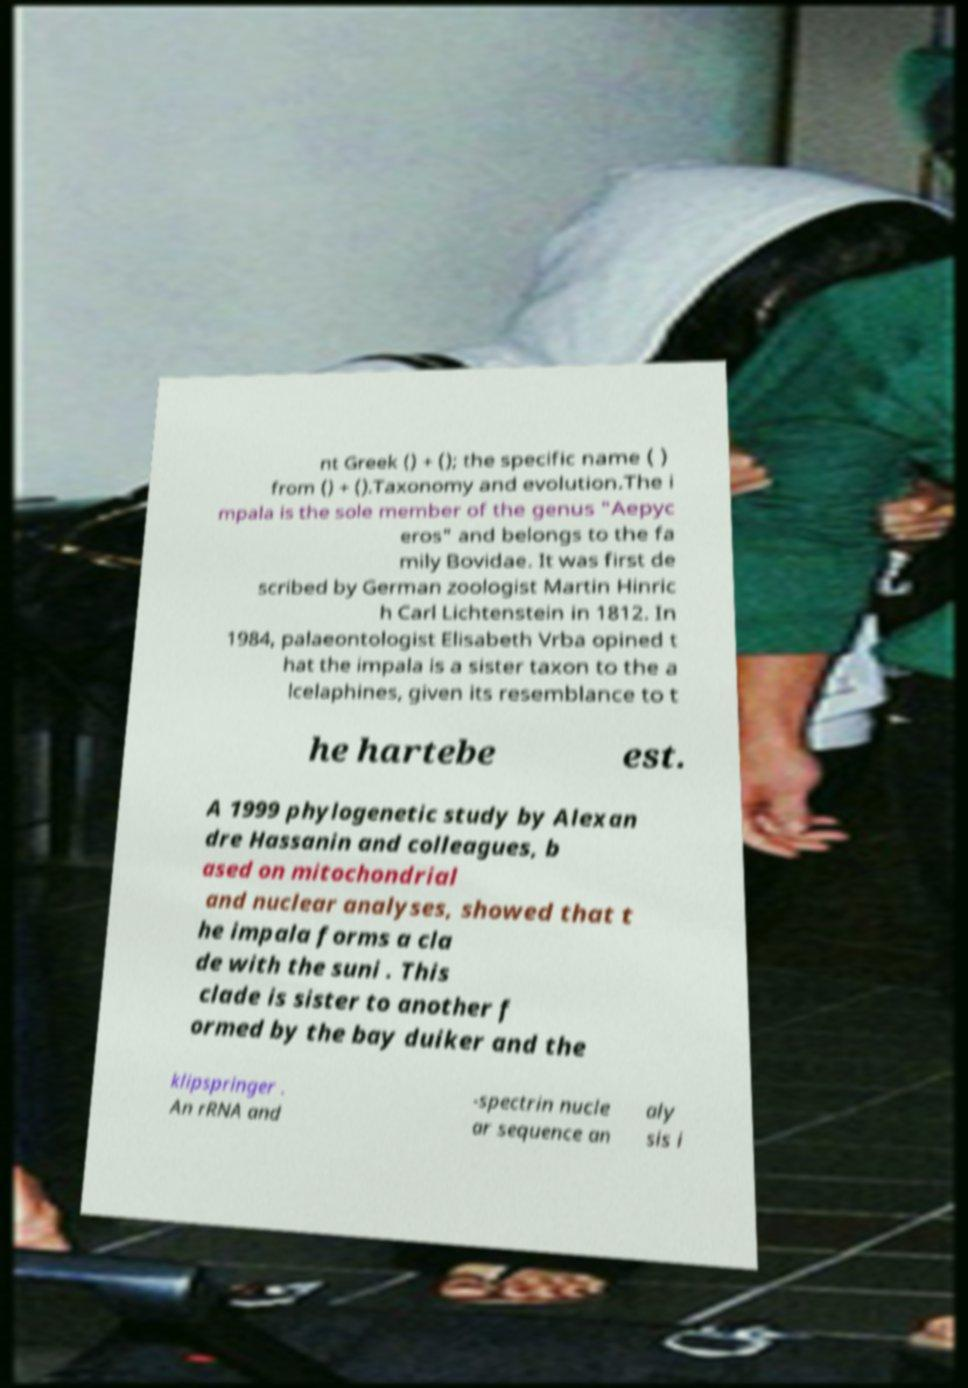Please read and relay the text visible in this image. What does it say? nt Greek () + (); the specific name ( ) from () + ().Taxonomy and evolution.The i mpala is the sole member of the genus "Aepyc eros" and belongs to the fa mily Bovidae. It was first de scribed by German zoologist Martin Hinric h Carl Lichtenstein in 1812. In 1984, palaeontologist Elisabeth Vrba opined t hat the impala is a sister taxon to the a lcelaphines, given its resemblance to t he hartebe est. A 1999 phylogenetic study by Alexan dre Hassanin and colleagues, b ased on mitochondrial and nuclear analyses, showed that t he impala forms a cla de with the suni . This clade is sister to another f ormed by the bay duiker and the klipspringer . An rRNA and -spectrin nucle ar sequence an aly sis i 